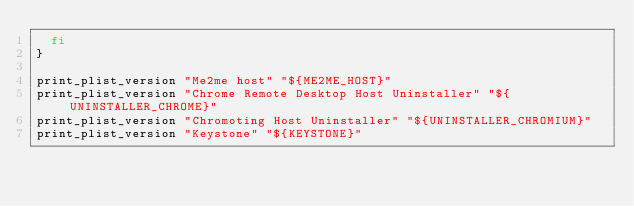<code> <loc_0><loc_0><loc_500><loc_500><_Bash_>  fi
}

print_plist_version "Me2me host" "${ME2ME_HOST}"
print_plist_version "Chrome Remote Desktop Host Uninstaller" "${UNINSTALLER_CHROME}"
print_plist_version "Chromoting Host Uninstaller" "${UNINSTALLER_CHROMIUM}"
print_plist_version "Keystone" "${KEYSTONE}"
</code> 